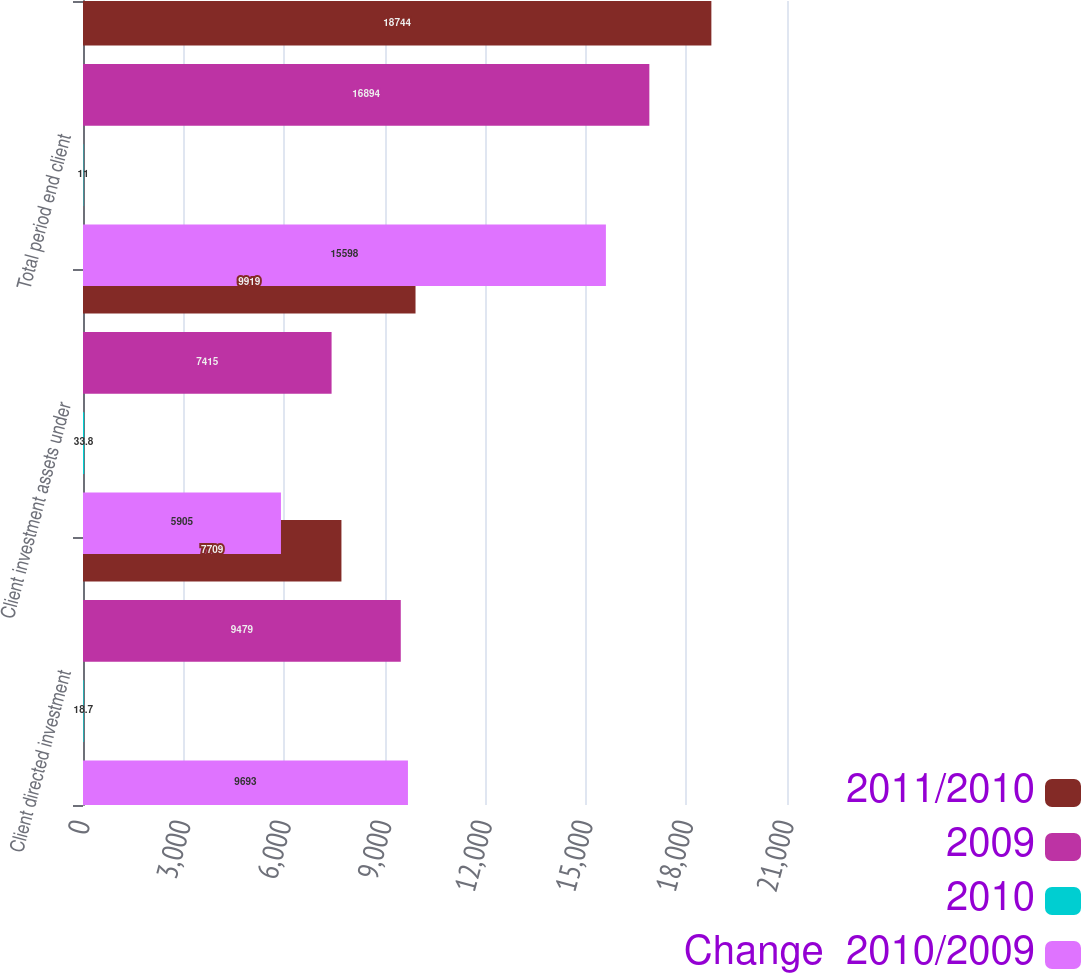Convert chart to OTSL. <chart><loc_0><loc_0><loc_500><loc_500><stacked_bar_chart><ecel><fcel>Client directed investment<fcel>Client investment assets under<fcel>Total period end client<nl><fcel>2011/2010<fcel>7709<fcel>9919<fcel>18744<nl><fcel>2009<fcel>9479<fcel>7415<fcel>16894<nl><fcel>2010<fcel>18.7<fcel>33.8<fcel>11<nl><fcel>Change  2010/2009<fcel>9693<fcel>5905<fcel>15598<nl></chart> 